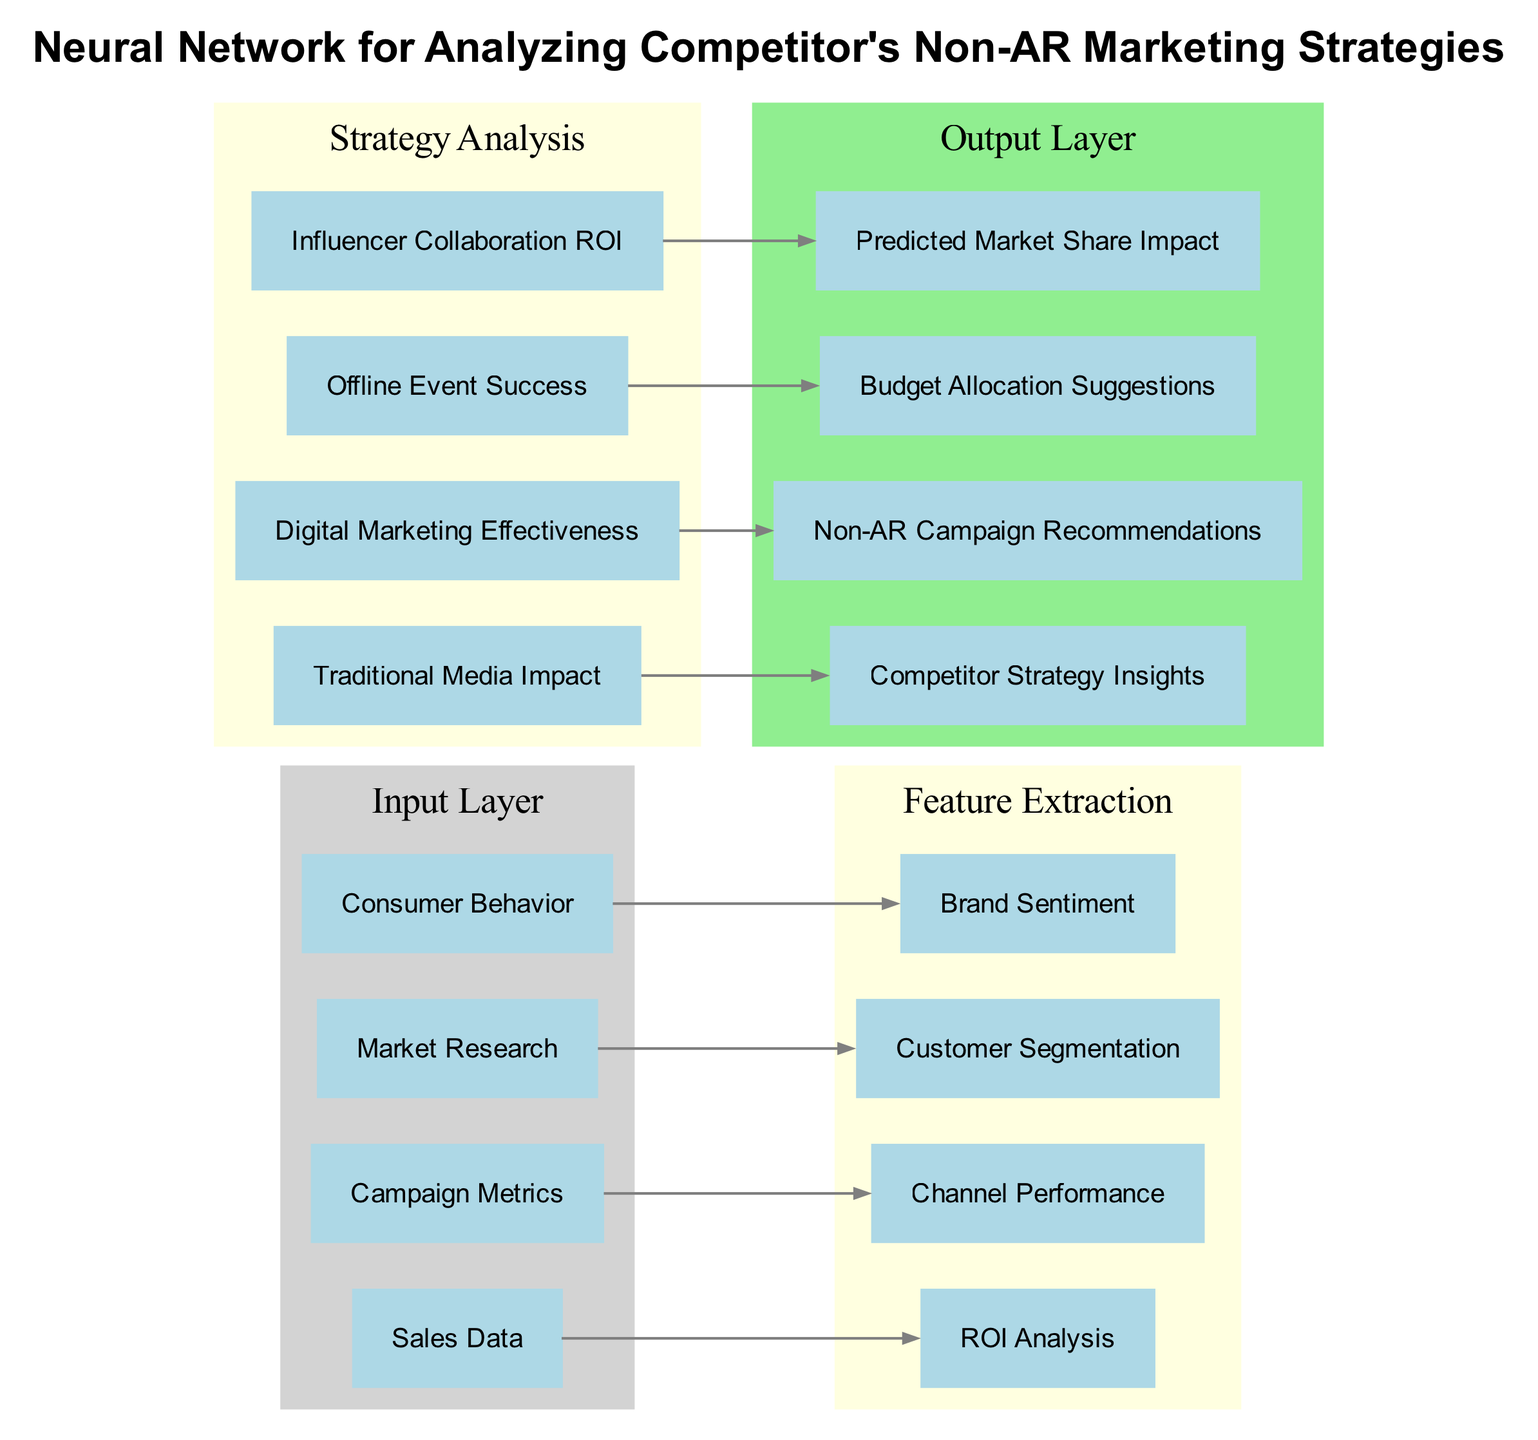What are the nodes in the input layer? The input layer consists of four nodes: Sales Data, Campaign Metrics, Market Research, and Consumer Behavior, each representing different aspects of data input for the neural network.
Answer: Sales Data, Campaign Metrics, Market Research, Consumer Behavior How many hidden layers are present in the diagram? There are two hidden layers in the diagram, as indicated by the sections labeled 'Feature Extraction' and 'Strategy Analysis.' Each layer contains its respective nodes for processing the data.
Answer: 2 Which node connects Sales Data? The Sales Data connects to the ROI Analysis node in the Feature Extraction hidden layer. This indicates that Sales Data is used to evaluate the return on investment.
Answer: ROI Analysis What is one of the outputs of this neural network? The output layer contains four nodes, one of which is Competitor Strategy Insights, providing insights based on the analysis performed by the network.
Answer: Competitor Strategy Insights What determines Non-AR Campaign Recommendations? The Non-AR Campaign Recommendations are determined by the Digital Marketing Effectiveness node, indicating that insights from digital marketing strategies are used to formulate campaign recommendations.
Answer: Digital Marketing Effectiveness How many total connections are there from the input layer to the hidden layers? There are four connections going from the input layer to the hidden layers, with each input node connecting to a specific node in the Feature Extraction hidden layer.
Answer: 4 Which hidden layer is focused on analyzing marketing strategies? The hidden layer named 'Strategy Analysis' focuses on analyzing marketing strategies, incorporating various nodes related to traditional media and digital marketing effectiveness.
Answer: Strategy Analysis What connects Offline Event Success to the output layer? Offline Event Success connects to the Budget Allocation Suggestions node in the output layer, suggesting that the success of events influences budget decisions.
Answer: Budget Allocation Suggestions Which node represents Brand Sentiment? The Brand Sentiment is represented in the Feature Extraction layer as a node that extracts insights regarding brand perception from Consumer Behavior data.
Answer: Brand Sentiment 